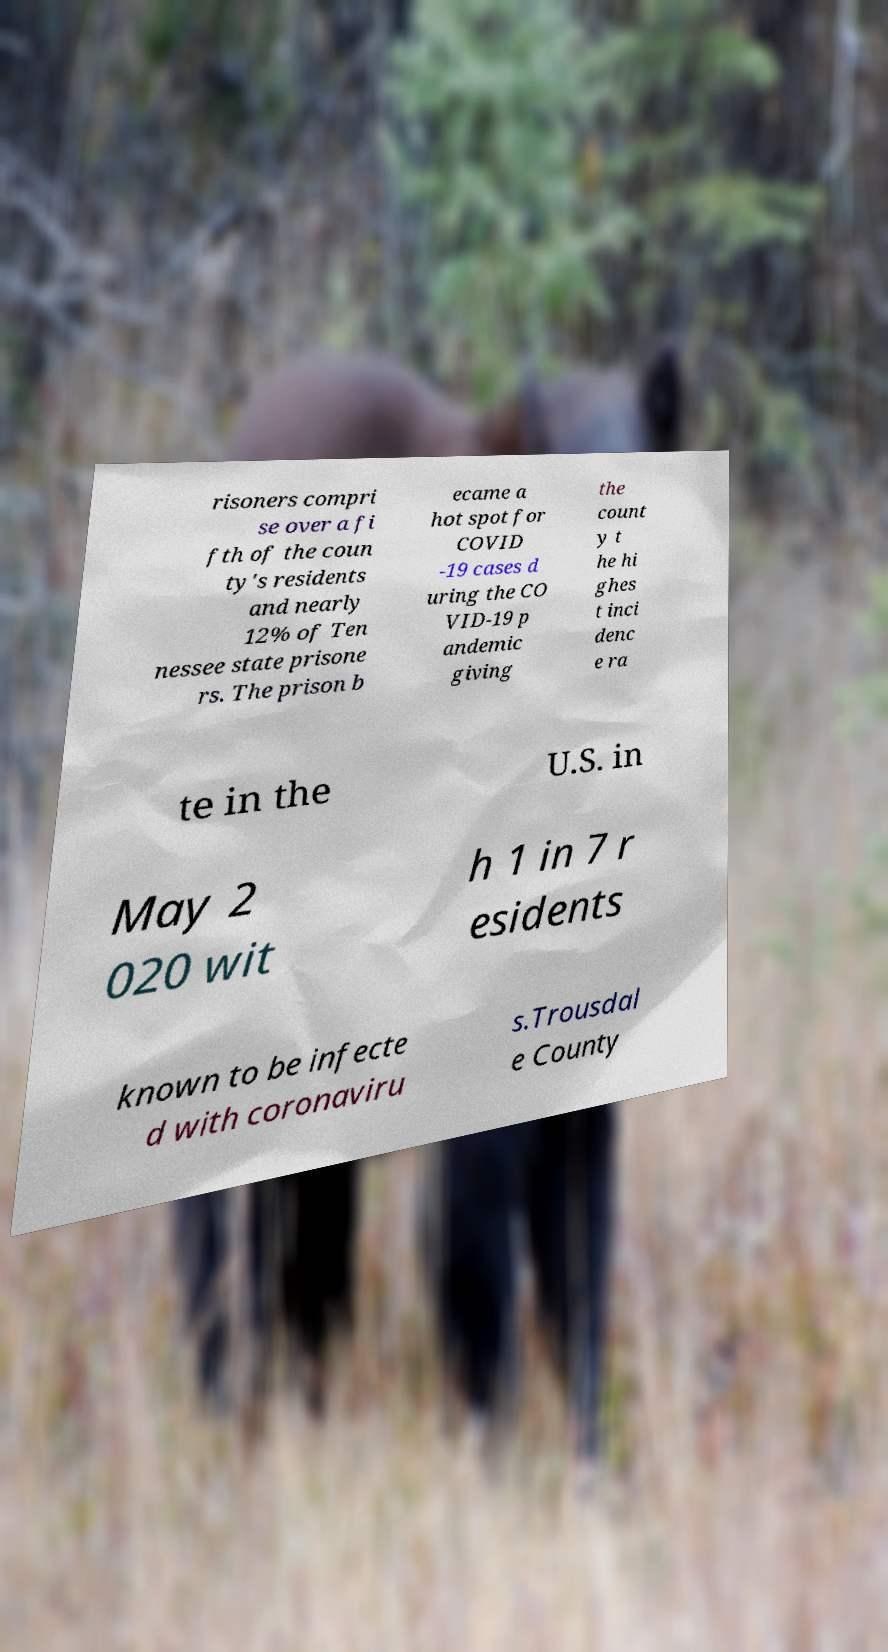Can you read and provide the text displayed in the image?This photo seems to have some interesting text. Can you extract and type it out for me? risoners compri se over a fi fth of the coun ty's residents and nearly 12% of Ten nessee state prisone rs. The prison b ecame a hot spot for COVID -19 cases d uring the CO VID-19 p andemic giving the count y t he hi ghes t inci denc e ra te in the U.S. in May 2 020 wit h 1 in 7 r esidents known to be infecte d with coronaviru s.Trousdal e County 